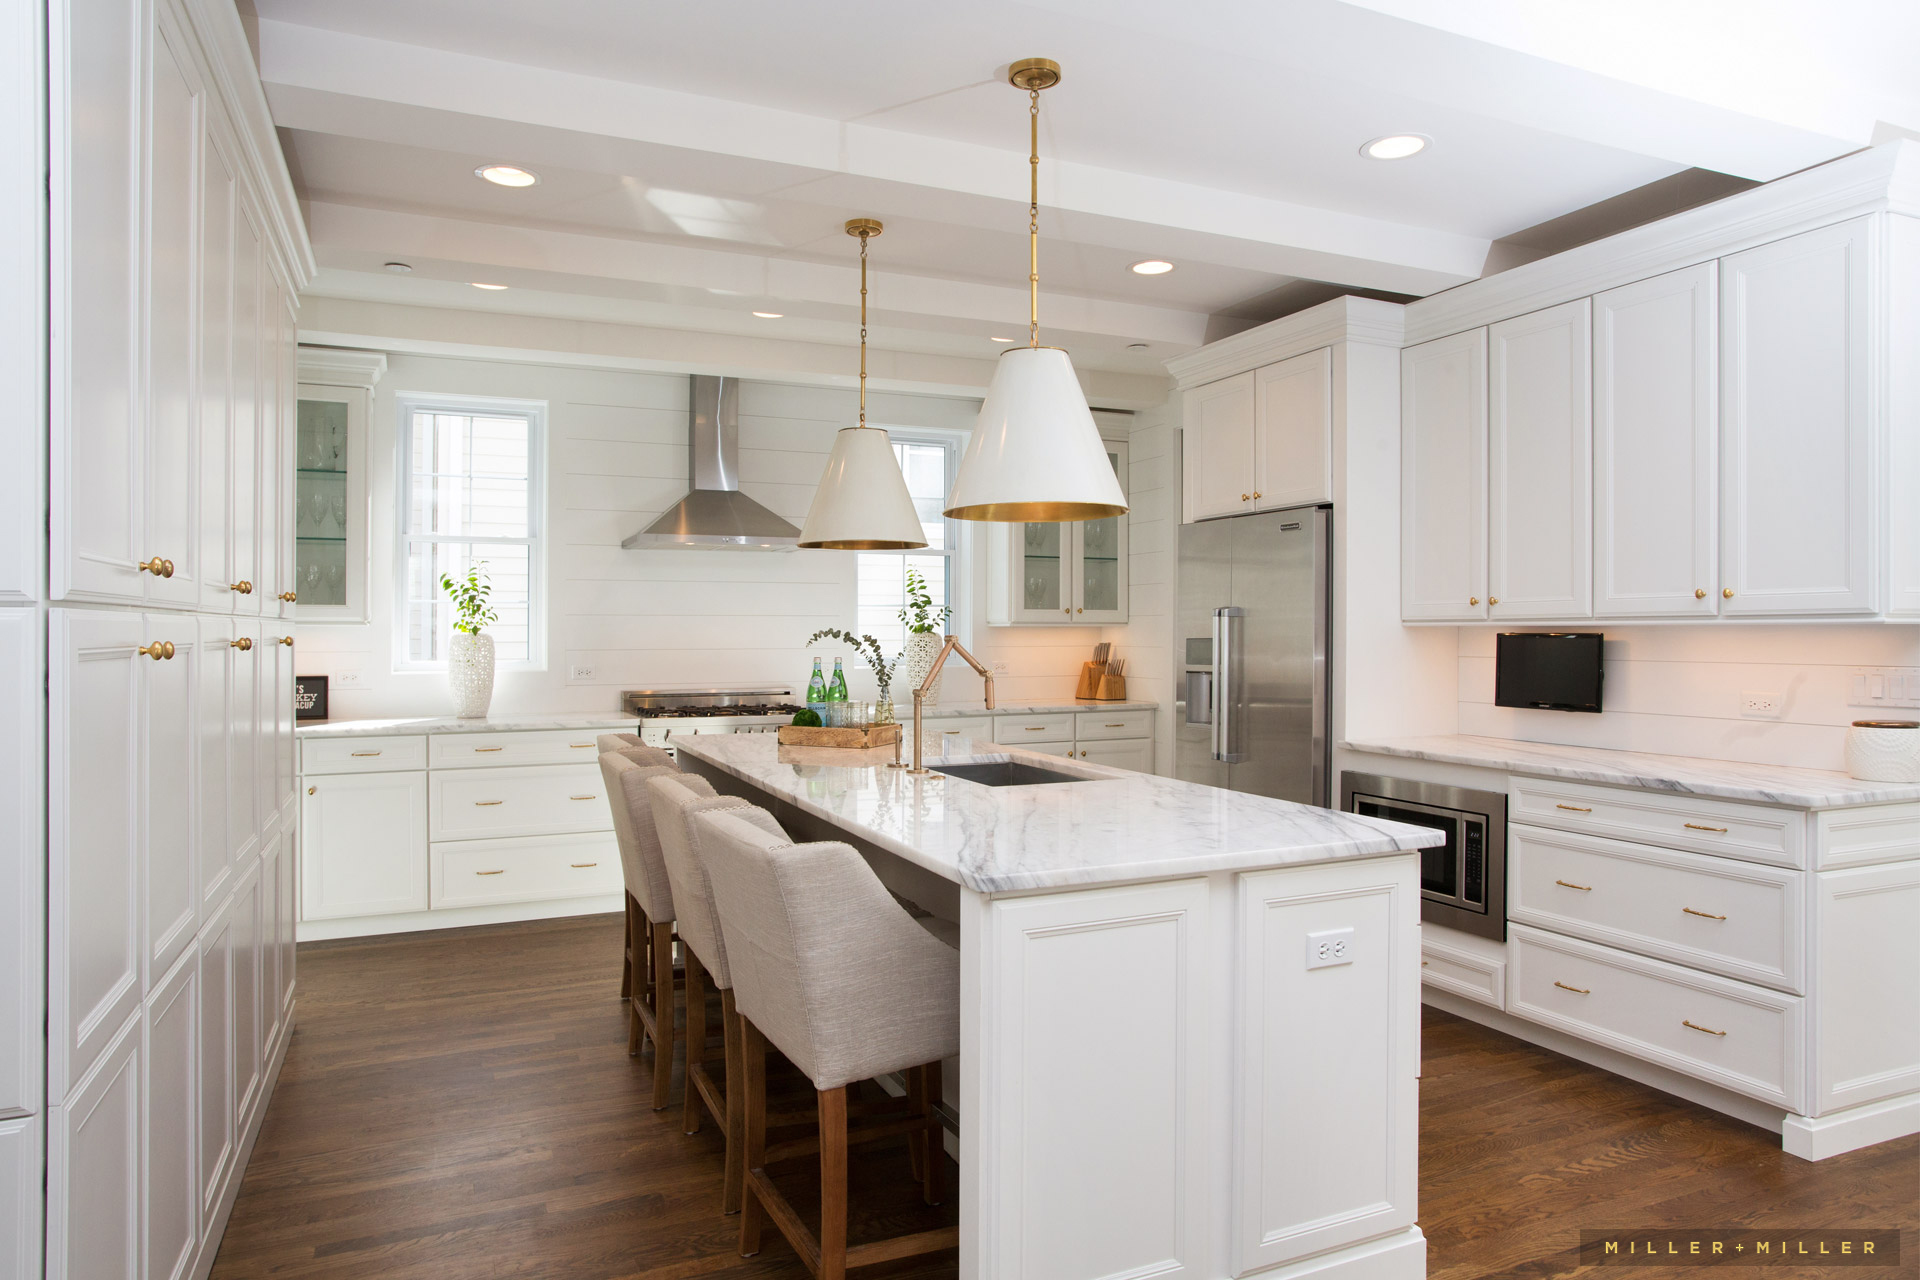Imagine a celebration being held in this kitchen. Picture a festive celebration in this beautifully designed kitchen. The island becomes the central hub, laden with an array of delicious appetizers, drinks, and festive decorations. The pendant lights above cast a warm glow over the space, enhancing the celebratory mood. Guests gather around the island, chatting and laughing, while some assist in last-minute meal preparations. The stainless steel appliances and ample counter space ensure everything is cooked to perfection. Children play in the adjoining rooms, their voices mingling with the happy hum of adult conversation. This kitchen seamlessly transforms into the heart of the celebration, embodying both joy and functionality. What innovative features could be added to this kitchen to make it even more versatile? To further enhance the versatility of this kitchen, several innovative features could be introduced. Incorporating smart technology, such as voice-activated controls for appliances and smart thermostats, would add convenience and efficiency. Installing an expandable island with additional seating or a hidden prepping station could provide extra space for both cooking and social interactions. Adding under-cabinet lighting with adjustable brightness would improve visibility and set various moods. Integrating a built-in coffee or wine station within the cabinetry could cater to specific entertaining needs, making the kitchen even more functional and enjoyable for daily use and gatherings. 